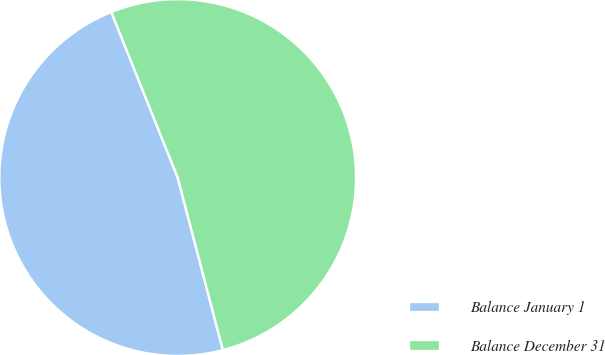<chart> <loc_0><loc_0><loc_500><loc_500><pie_chart><fcel>Balance January 1<fcel>Balance December 31<nl><fcel>48.01%<fcel>51.99%<nl></chart> 